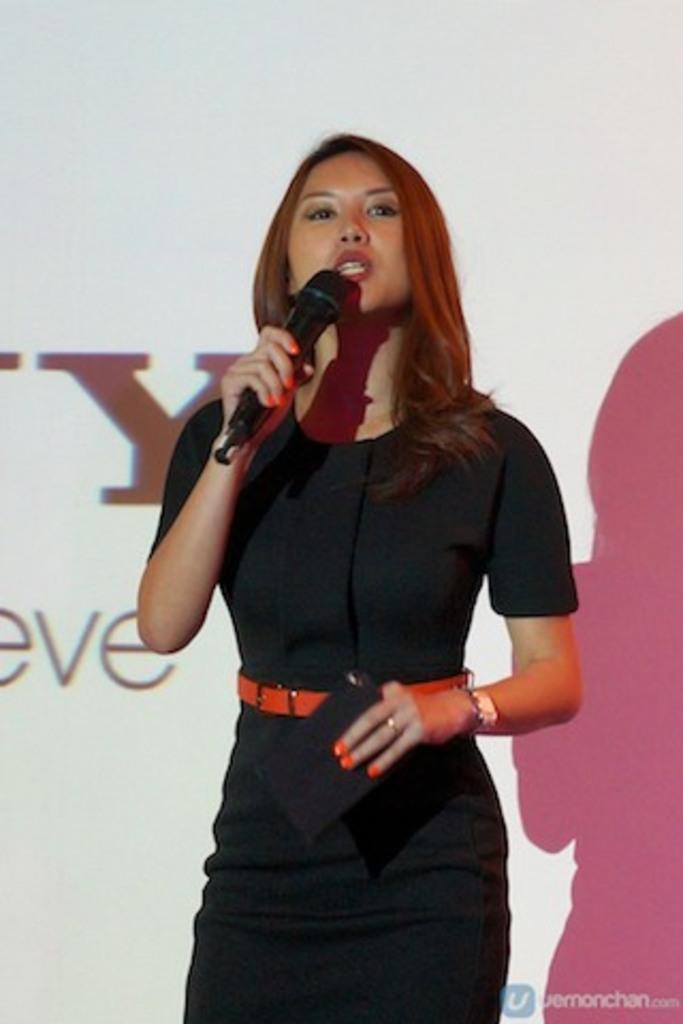Who is the main subject in the image? There is a woman in the image. What is the woman wearing? The woman is wearing a black dress. Can you describe any accessories the woman is wearing? The woman has a watch on her hand. What is the woman holding in the image? The woman is holding a microphone. What is the woman doing in the image? The woman is talking in the image. What type of plate is the woman holding in the image? There is no plate present in the image; the woman is holding a microphone. What kind of jewel is the woman wearing on her wrist? The woman is not wearing a jewel on her wrist; she is wearing a watch. 